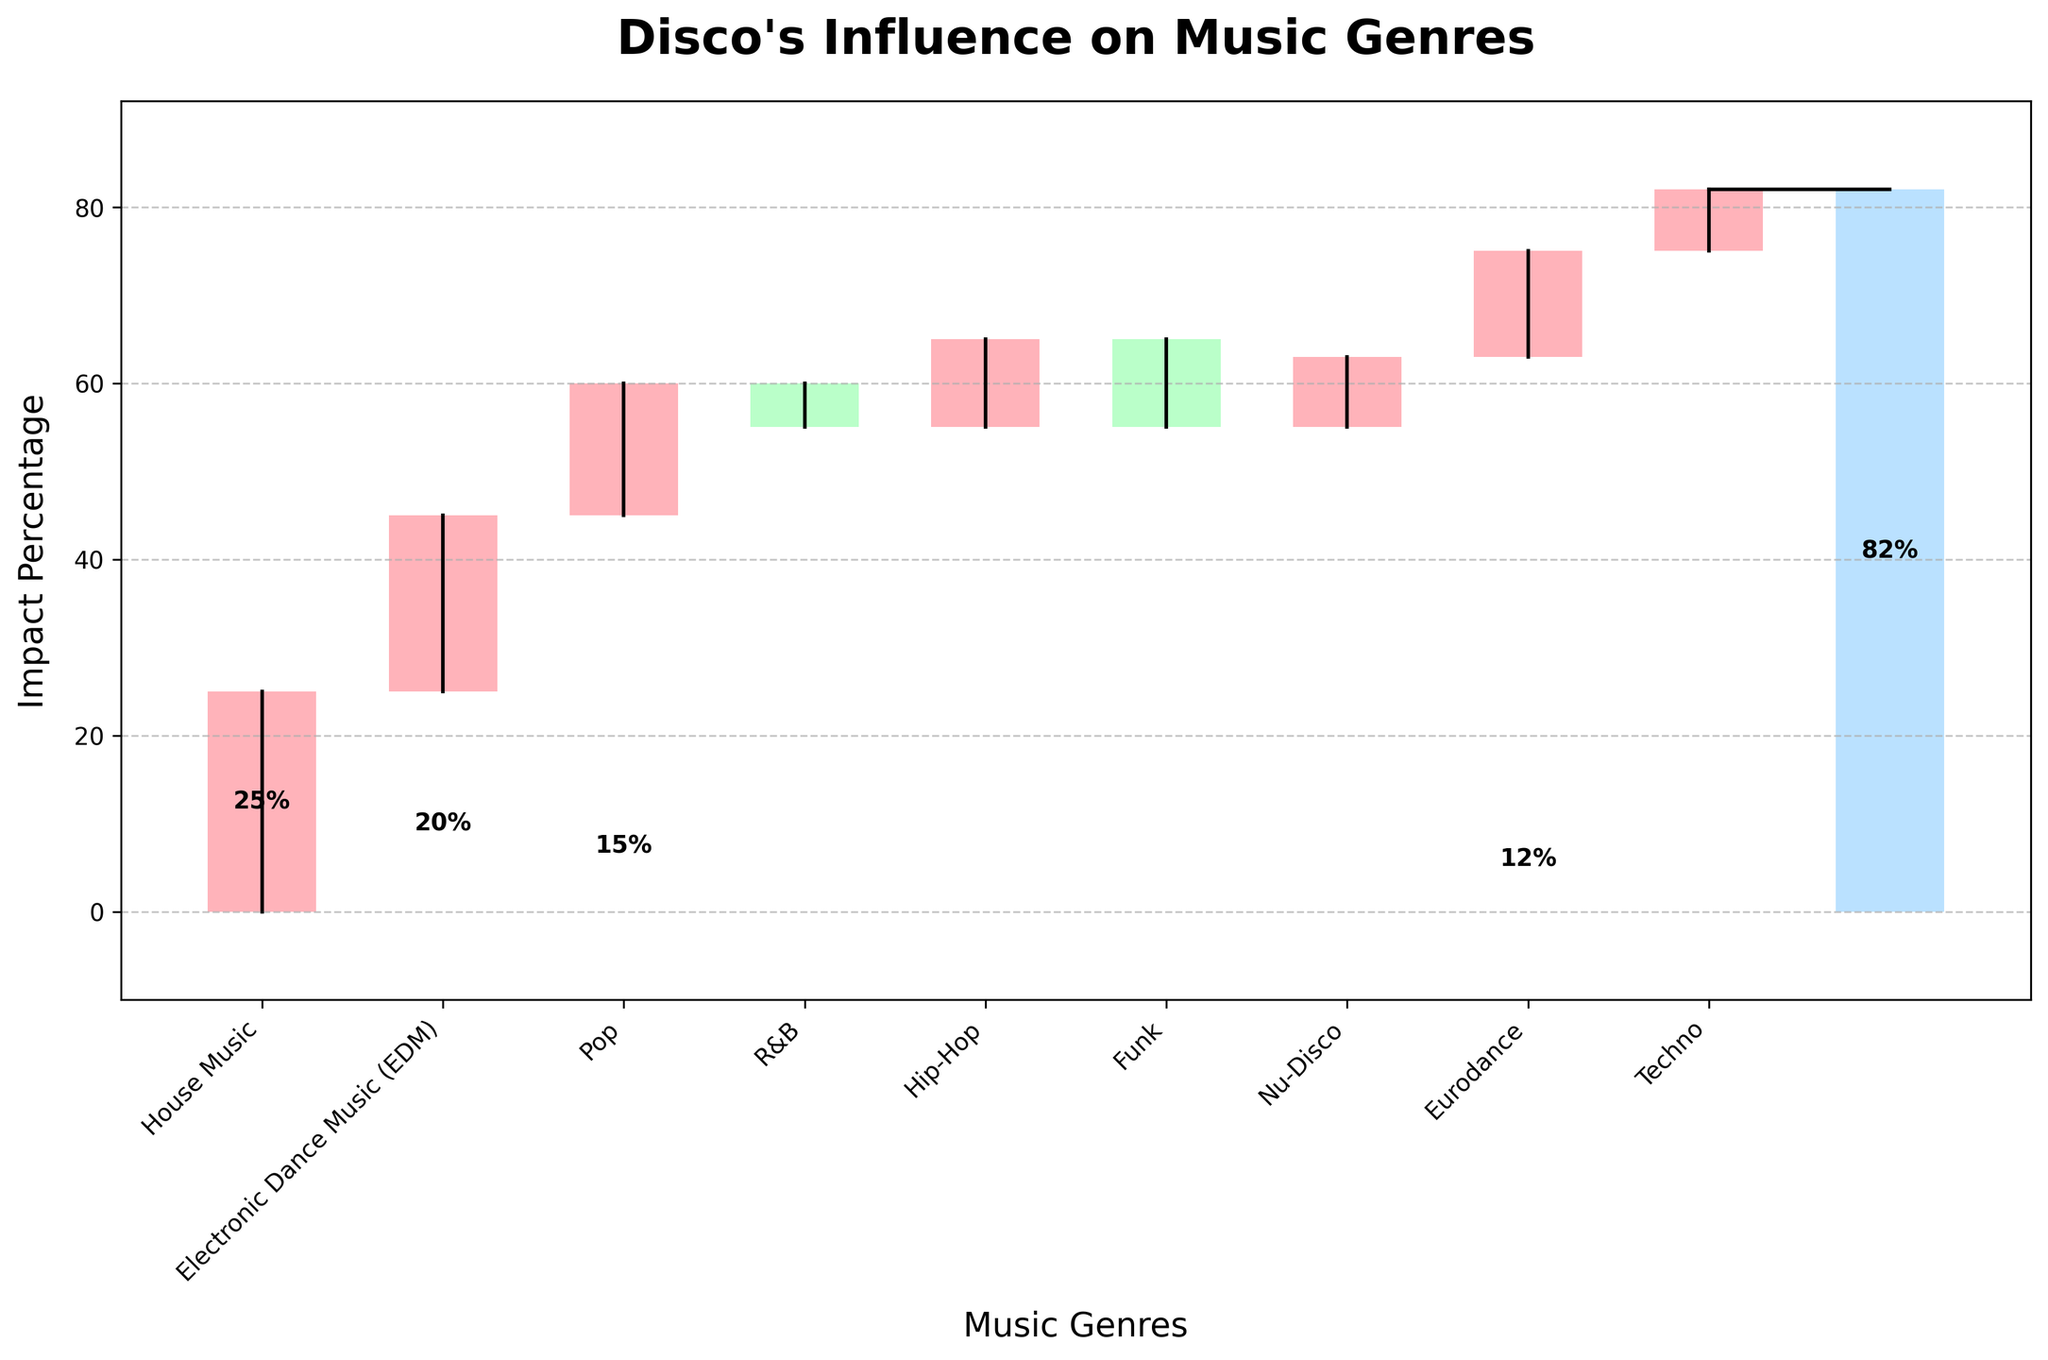What's the total impact percentage of disco's influence on music genres? The title "Disco's Influence on Music Genres" suggests an overall impact. The last bar corresponding to "Total" shows an impact of 82%.
Answer: 82% Which genre has the highest positive impact from disco? Looking at the chart, the tallest positive bar is for House Music.
Answer: House Music Which genre shows a negative impact from disco? The genres with bars extending below the x-axis are R&B and Funk.
Answer: R&B and Funk How does the impact of disco on EDM compare to the impact on Techno? The height of the bars for EDM and Techno should be compared. EDM has a 20% impact, while Techno has a 7% impact, making EDM higher.
Answer: EDM is higher What's the combined impact of disco on Nu-Disco and Eurodance? Add the impact percentages for Nu-Disco (8%) and Eurodance (12%). 8 + 12 = 20
Answer: 20% What is the cumulative impact right before the total bar? The cumulative sum right before the total would be the sum of previous impacts, which aligns with the bar right before "Total". The value is 75%.
Answer: 75% Which genres have an impact percentage less than 10% and more than 5%? Check the bars that fall in the 5-10% range. Techno (7%) qualifies.
Answer: Techno How much less impact does Funk have compared to Pop? Pop has an impact of 15%, while Funk has -10%. The difference is 15 - (-10) = 25%.
Answer: 25% What is the average positive impact of disco across all genres? Sum the positive impacts (25 + 20 + 15 + 10 + 8 + 12 + 7 = 97) and divide by the number of positive impact genres (7). Average = 97 / 7 ≈ 13.86.
Answer: 13.86% Is the impact on Hip-Hop greater or less than on Pop? Compare the heights: Hip-Hop has a 10% impact, while Pop has a 15% impact. Hip-Hop is less.
Answer: Less 